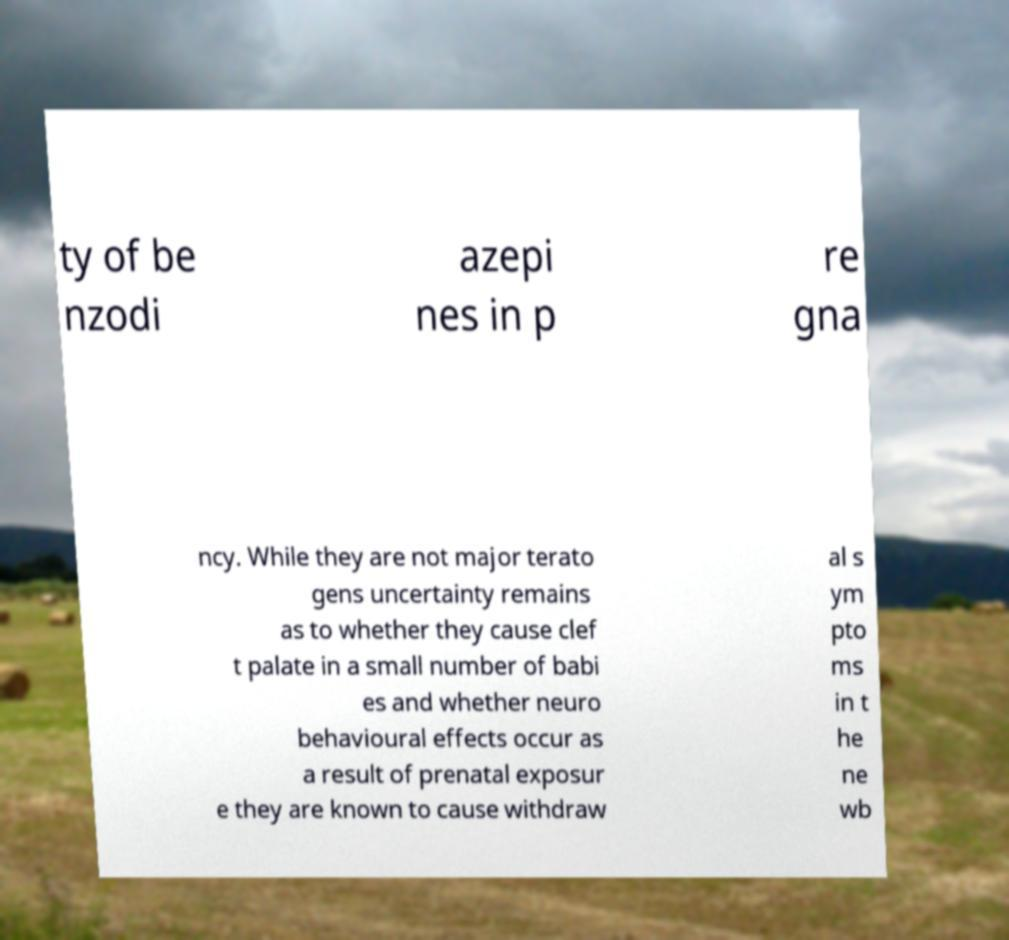Please identify and transcribe the text found in this image. ty of be nzodi azepi nes in p re gna ncy. While they are not major terato gens uncertainty remains as to whether they cause clef t palate in a small number of babi es and whether neuro behavioural effects occur as a result of prenatal exposur e they are known to cause withdraw al s ym pto ms in t he ne wb 